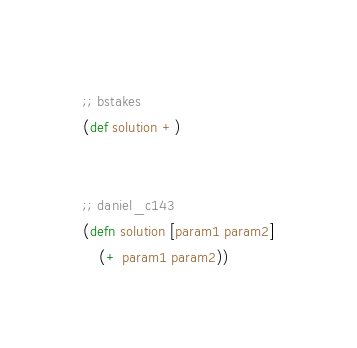<code> <loc_0><loc_0><loc_500><loc_500><_Clojure_>;; bstakes
(def solution +)


;; daniel_c143
(defn solution [param1 param2]
    (+ param1 param2))

</code> 